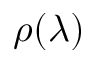<formula> <loc_0><loc_0><loc_500><loc_500>\rho ( \lambda )</formula> 